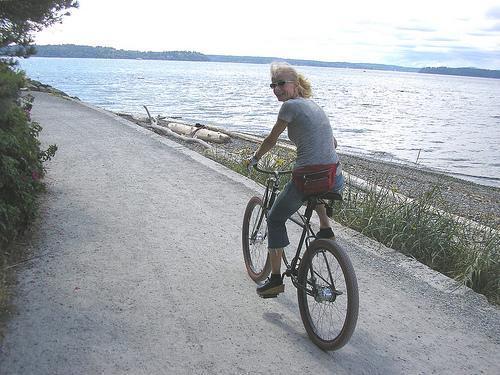How many bicycles are in the picture?
Give a very brief answer. 1. 